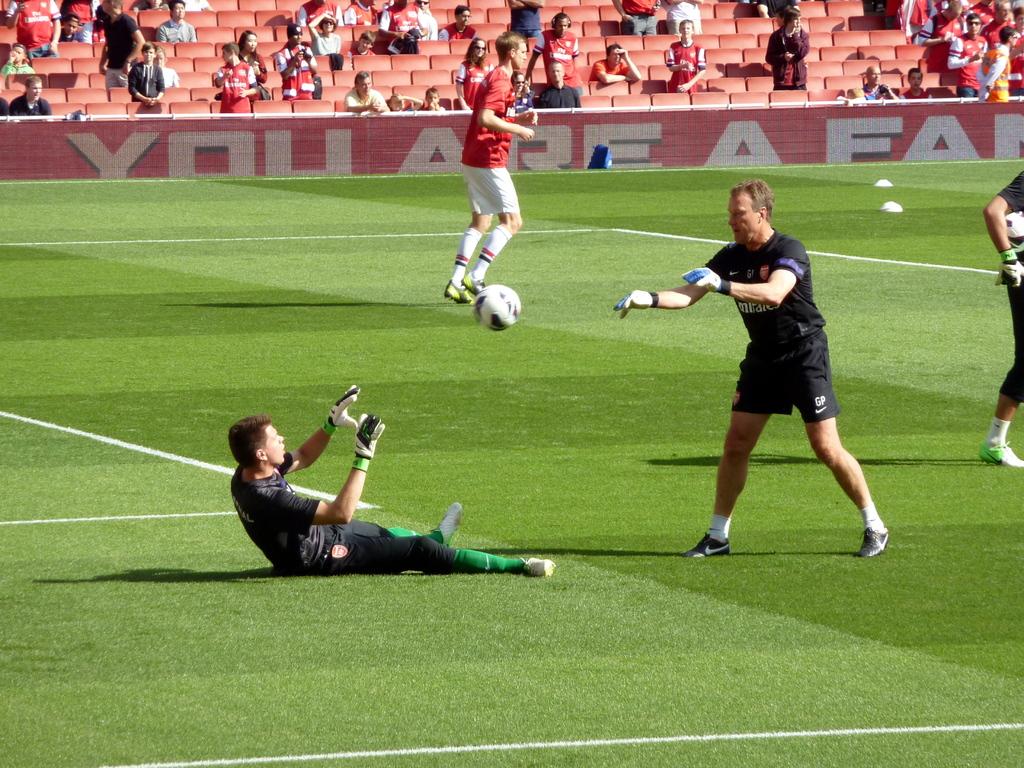What does the sign say in the background, telling what you are?
Give a very brief answer. You are a fan. What letters are above the nike logo on the black shorts?
Offer a very short reply. Gp. 